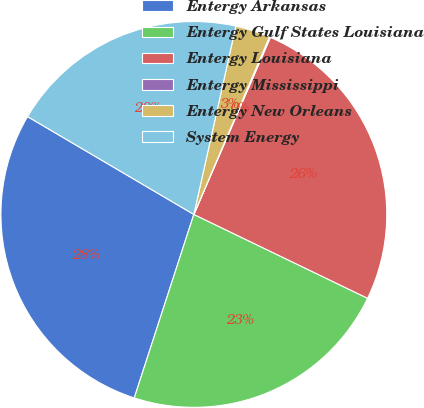Convert chart to OTSL. <chart><loc_0><loc_0><loc_500><loc_500><pie_chart><fcel>Entergy Arkansas<fcel>Entergy Gulf States Louisiana<fcel>Entergy Louisiana<fcel>Entergy Mississippi<fcel>Entergy New Orleans<fcel>System Energy<nl><fcel>28.47%<fcel>22.84%<fcel>25.66%<fcel>0.09%<fcel>2.91%<fcel>20.03%<nl></chart> 